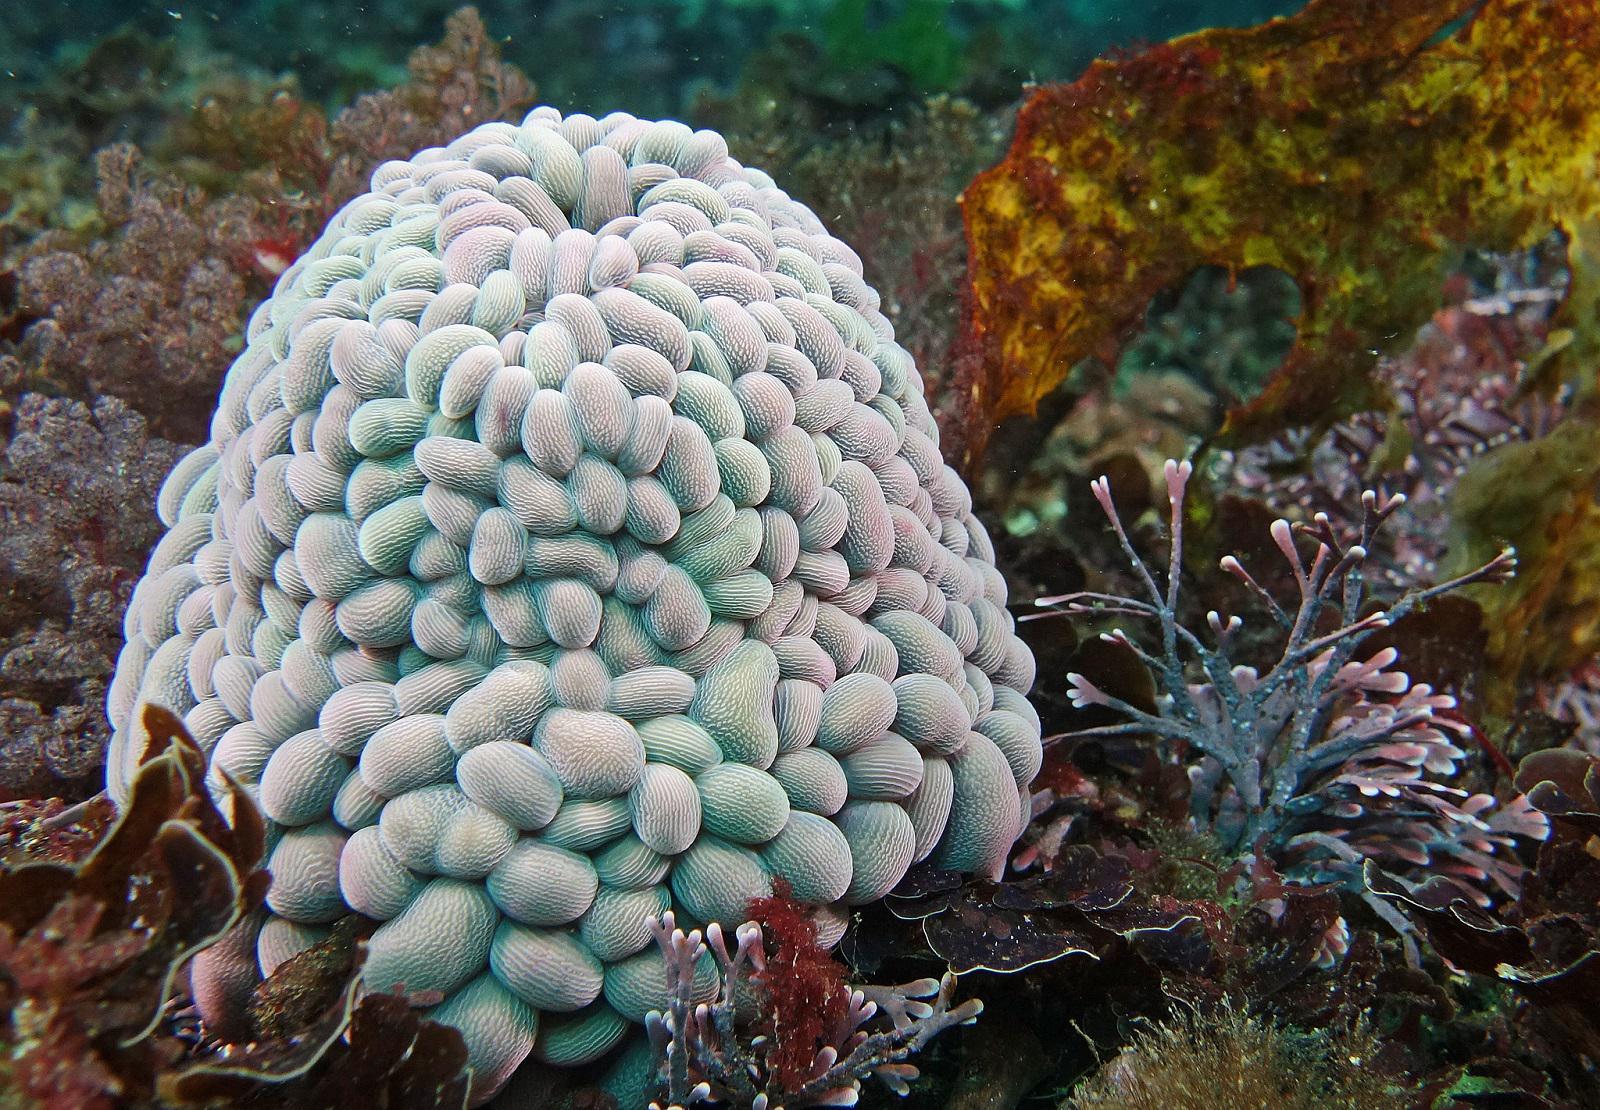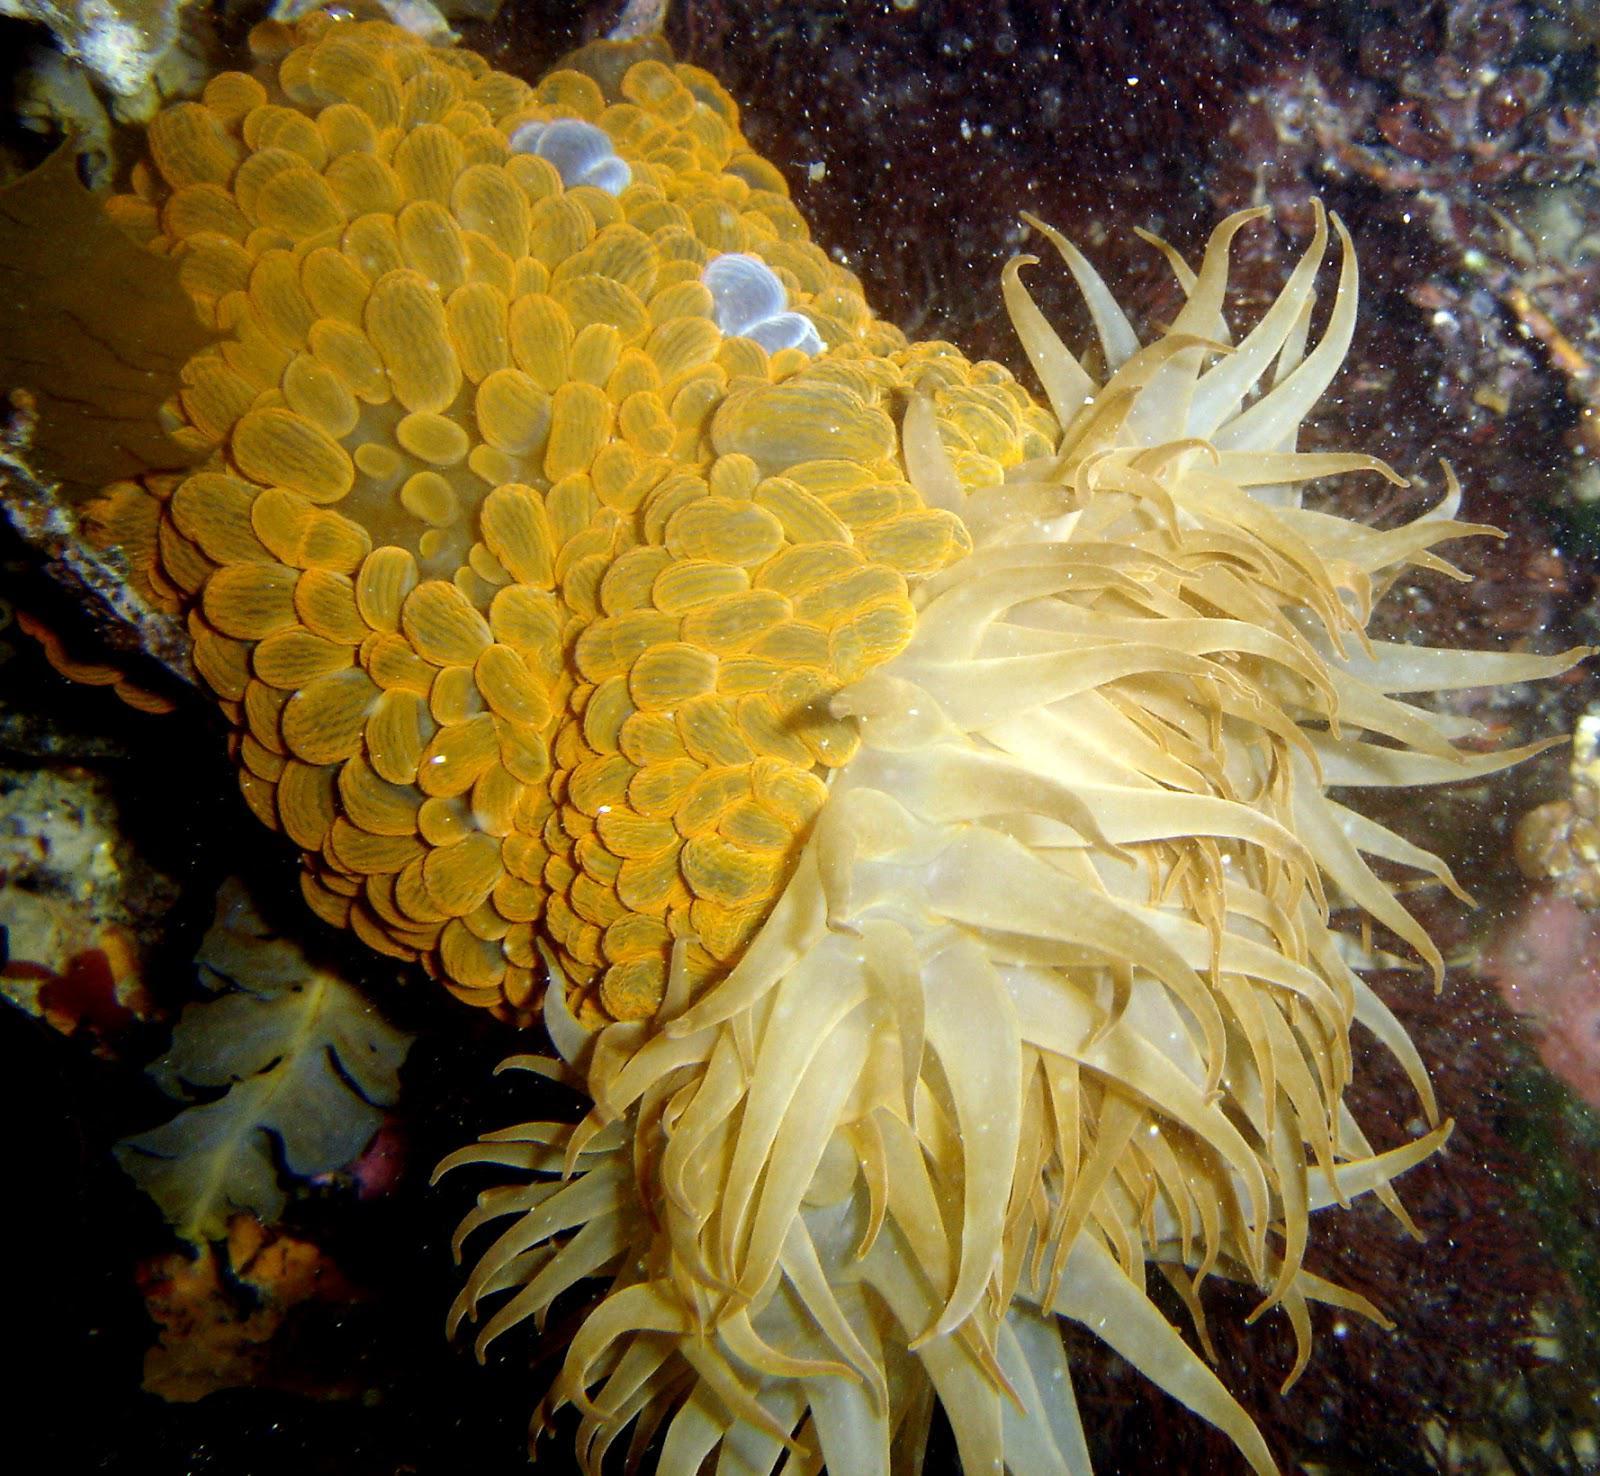The first image is the image on the left, the second image is the image on the right. For the images displayed, is the sentence "One of the objects is closed and the other is at least partially open." factually correct? Answer yes or no. Yes. The first image is the image on the left, the second image is the image on the right. Examine the images to the left and right. Is the description "The right image shows anemone tendrils emerging from a stalk covered with oval shapes." accurate? Answer yes or no. Yes. 